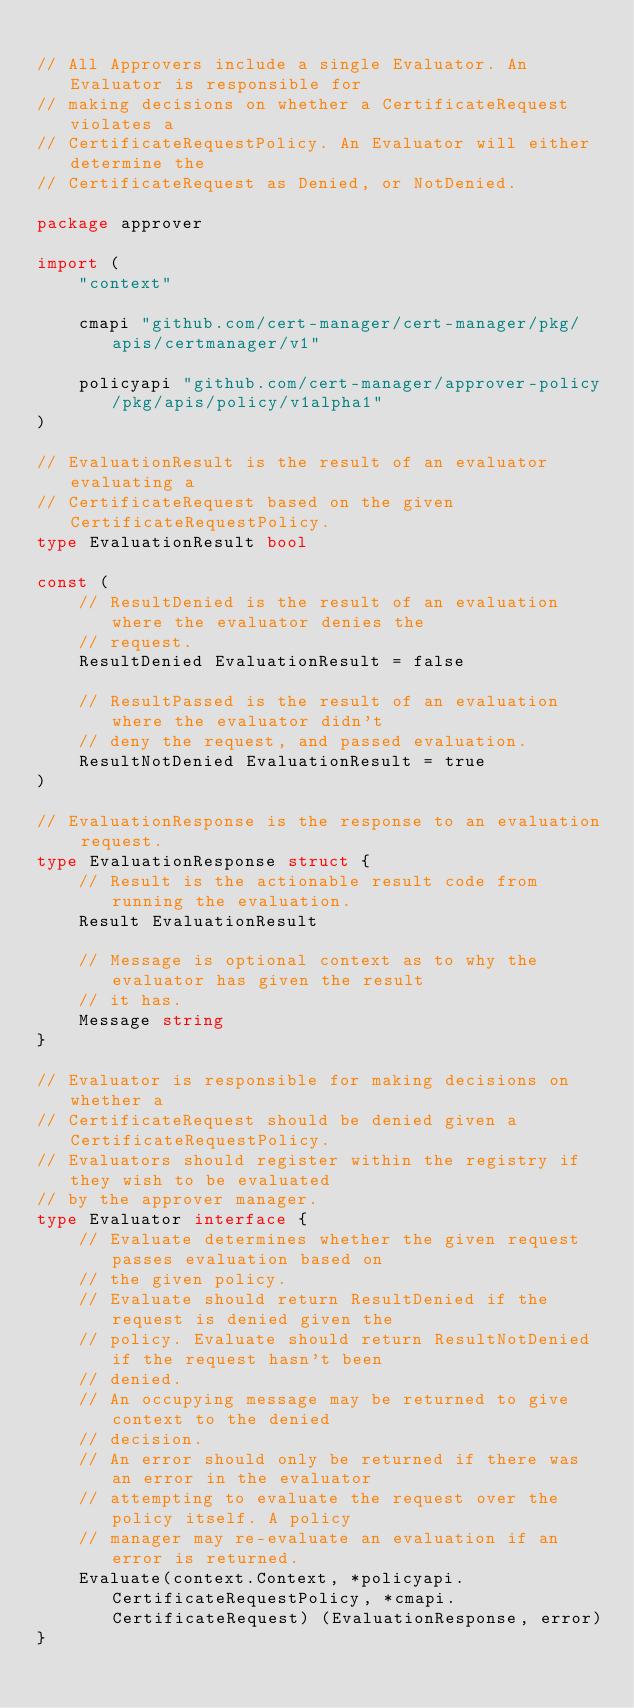<code> <loc_0><loc_0><loc_500><loc_500><_Go_>
// All Approvers include a single Evaluator. An Evaluator is responsible for
// making decisions on whether a CertificateRequest violates a
// CertificateRequestPolicy. An Evaluator will either determine the
// CertificateRequest as Denied, or NotDenied.

package approver

import (
	"context"

	cmapi "github.com/cert-manager/cert-manager/pkg/apis/certmanager/v1"

	policyapi "github.com/cert-manager/approver-policy/pkg/apis/policy/v1alpha1"
)

// EvaluationResult is the result of an evaluator evaluating a
// CertificateRequest based on the given CertificateRequestPolicy.
type EvaluationResult bool

const (
	// ResultDenied is the result of an evaluation where the evaluator denies the
	// request.
	ResultDenied EvaluationResult = false

	// ResultPassed is the result of an evaluation where the evaluator didn't
	// deny the request, and passed evaluation.
	ResultNotDenied EvaluationResult = true
)

// EvaluationResponse is the response to an evaluation request.
type EvaluationResponse struct {
	// Result is the actionable result code from running the evaluation.
	Result EvaluationResult

	// Message is optional context as to why the evaluator has given the result
	// it has.
	Message string
}

// Evaluator is responsible for making decisions on whether a
// CertificateRequest should be denied given a CertificateRequestPolicy.
// Evaluators should register within the registry if they wish to be evaluated
// by the approver manager.
type Evaluator interface {
	// Evaluate determines whether the given request passes evaluation based on
	// the given policy.
	// Evaluate should return ResultDenied if the request is denied given the
	// policy. Evaluate should return ResultNotDenied if the request hasn't been
	// denied.
	// An occupying message may be returned to give context to the denied
	// decision.
	// An error should only be returned if there was an error in the evaluator
	// attempting to evaluate the request over the policy itself. A policy
	// manager may re-evaluate an evaluation if an error is returned.
	Evaluate(context.Context, *policyapi.CertificateRequestPolicy, *cmapi.CertificateRequest) (EvaluationResponse, error)
}
</code> 